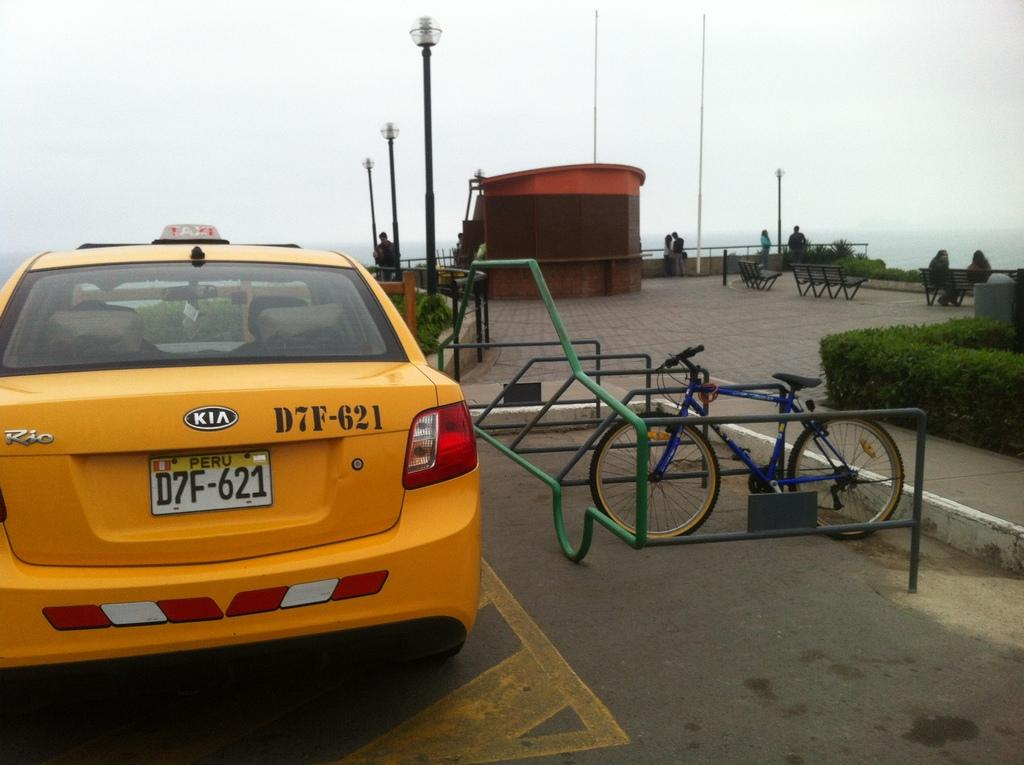Provide a one-sentence caption for the provided image. A yellow taxi with the license plate of D7F-621 is parked near a bike. 